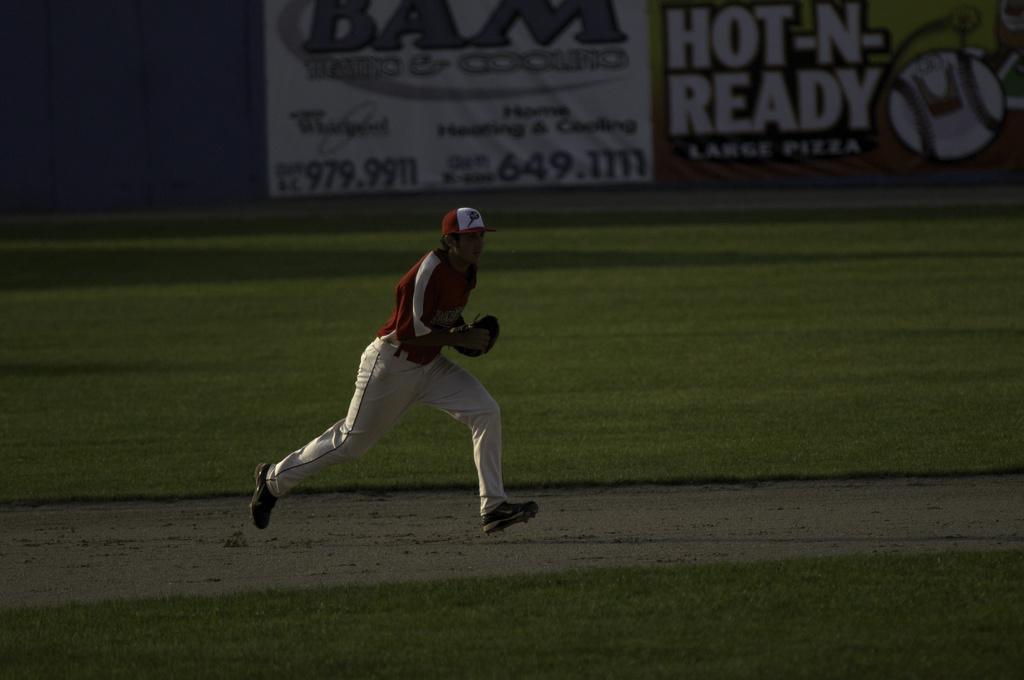In one or two sentences, can you explain what this image depicts? In this picture there is a man in the center of the image, it seems to be he is running and there is grassland and posters in the image. 